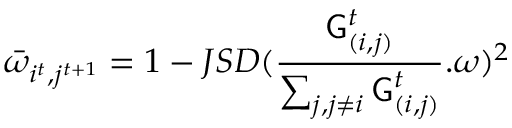Convert formula to latex. <formula><loc_0><loc_0><loc_500><loc_500>\bar { \omega } _ { i ^ { t } , j ^ { t + 1 } } = 1 - J S D ( \frac { G _ { ( i , j ) } ^ { t } } { \sum _ { j , j \neq i } G _ { ( i , j ) } ^ { t } } . \omega ) ^ { 2 }</formula> 